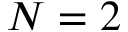<formula> <loc_0><loc_0><loc_500><loc_500>N = 2</formula> 